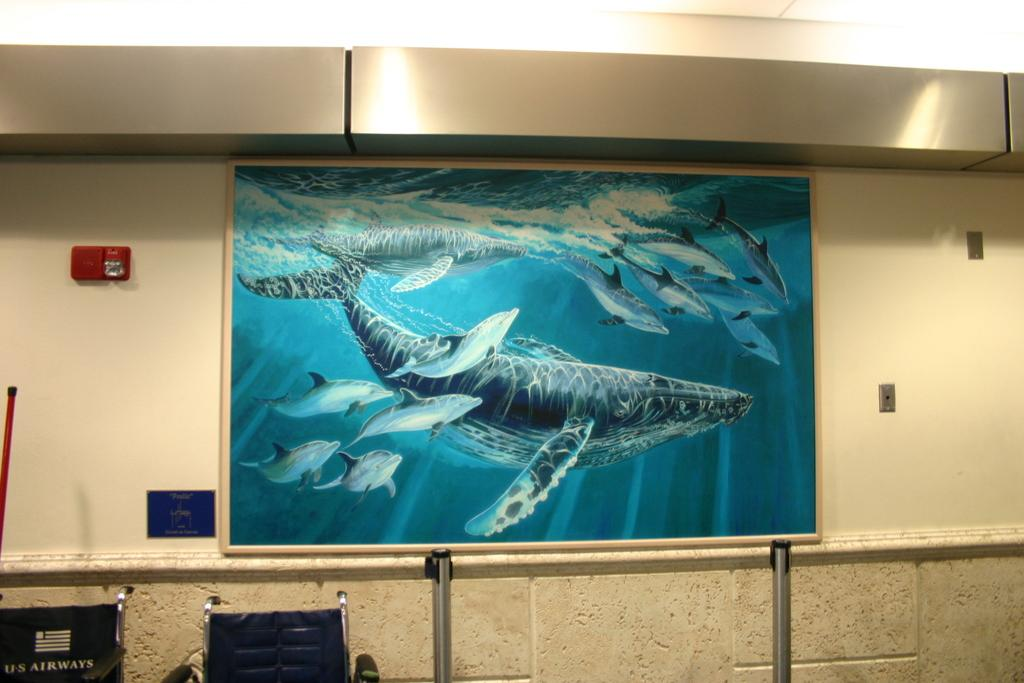What type of furniture is present in the image? There are stands and chairs in the image. What can be seen in the image that is used for holding or displaying items? There is a red stick in the image. What is on the wall in the image? There is a frame, a board, and a red box on the wall. What time of day is depicted in the image, and what army is present? The time of day and any army presence cannot be determined from the image, as it does not contain any information about the time or any military involvement. What scientific theory is being discussed in the image? There is no discussion of a scientific theory in the image, as it does not contain any text or context to suggest such a topic. 